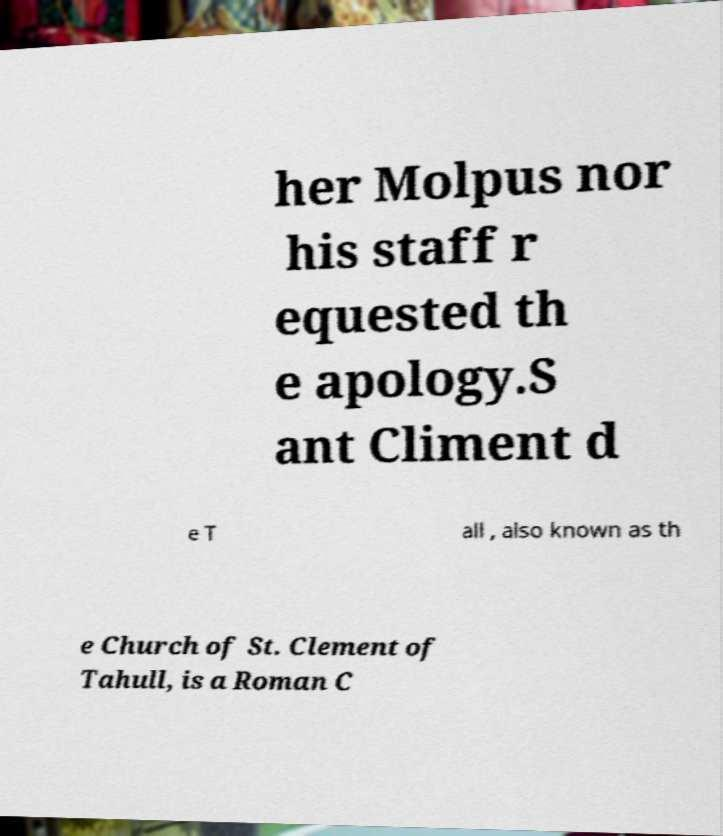Please identify and transcribe the text found in this image. her Molpus nor his staff r equested th e apology.S ant Climent d e T all , also known as th e Church of St. Clement of Tahull, is a Roman C 